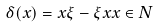Convert formula to latex. <formula><loc_0><loc_0><loc_500><loc_500>\delta ( x ) = x \xi - \xi x x \in N</formula> 